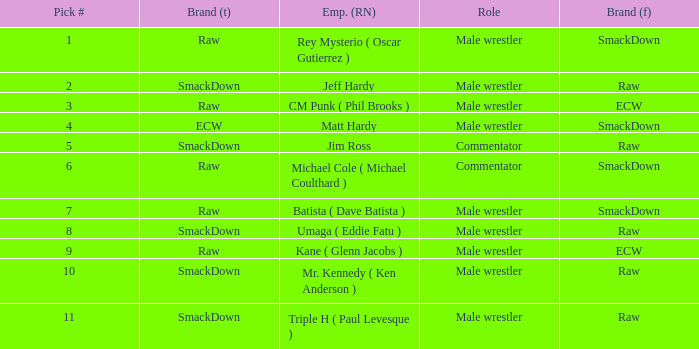Pick # 3 works for which brand? ECW. 